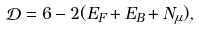<formula> <loc_0><loc_0><loc_500><loc_500>\mathcal { D } = 6 - 2 ( E _ { F } + E _ { B } + N _ { \mu } ) ,</formula> 